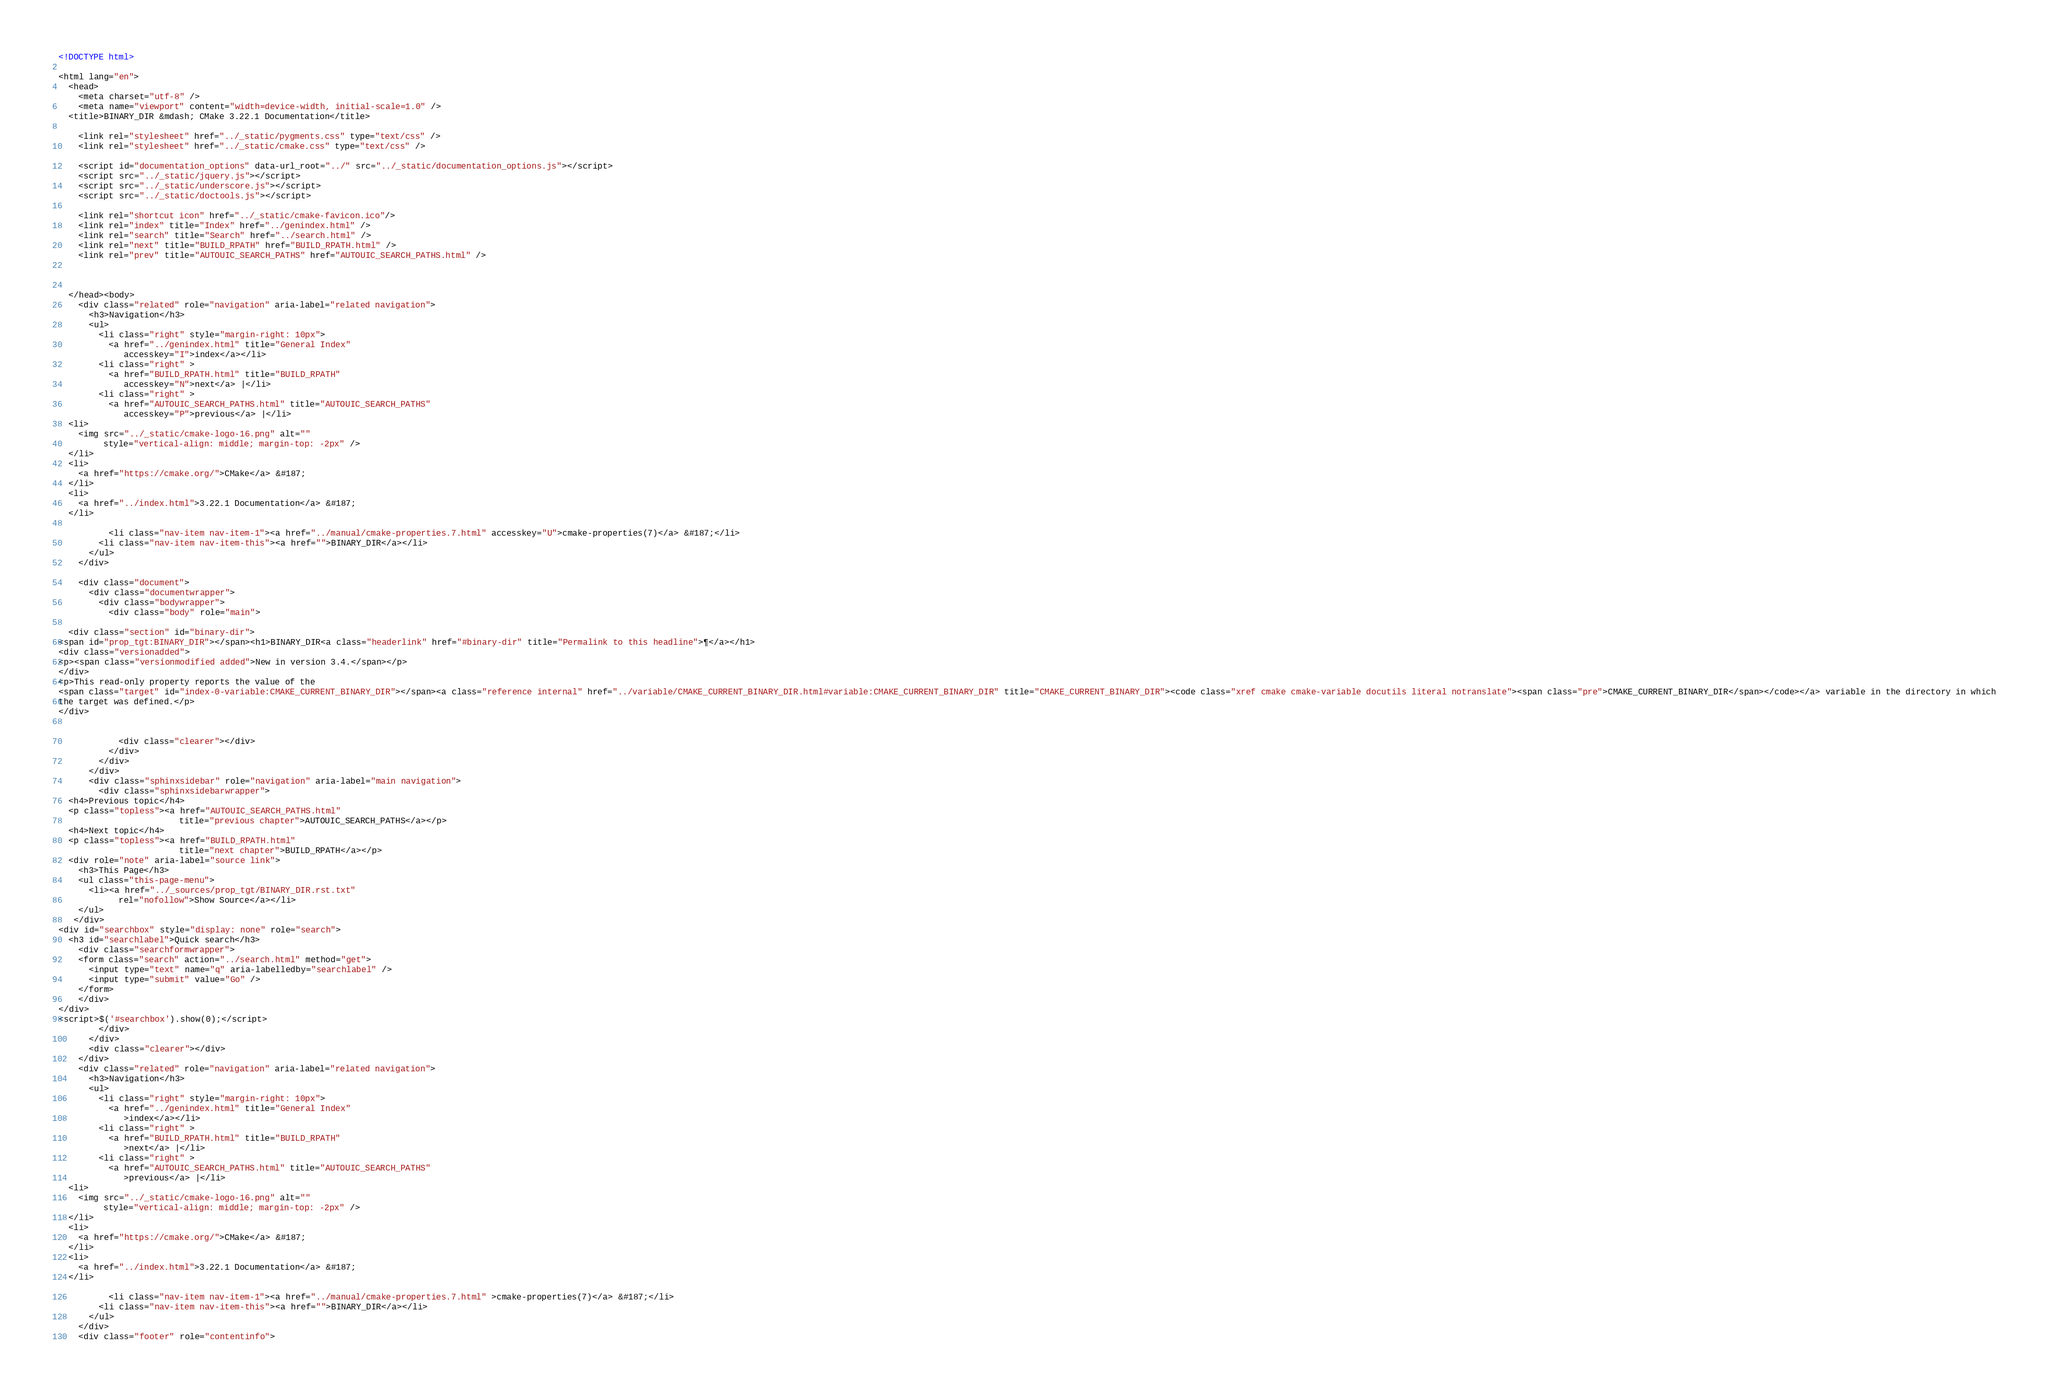Convert code to text. <code><loc_0><loc_0><loc_500><loc_500><_HTML_>
<!DOCTYPE html>

<html lang="en">
  <head>
    <meta charset="utf-8" />
    <meta name="viewport" content="width=device-width, initial-scale=1.0" />
  <title>BINARY_DIR &mdash; CMake 3.22.1 Documentation</title>

    <link rel="stylesheet" href="../_static/pygments.css" type="text/css" />
    <link rel="stylesheet" href="../_static/cmake.css" type="text/css" />
    
    <script id="documentation_options" data-url_root="../" src="../_static/documentation_options.js"></script>
    <script src="../_static/jquery.js"></script>
    <script src="../_static/underscore.js"></script>
    <script src="../_static/doctools.js"></script>
    
    <link rel="shortcut icon" href="../_static/cmake-favicon.ico"/>
    <link rel="index" title="Index" href="../genindex.html" />
    <link rel="search" title="Search" href="../search.html" />
    <link rel="next" title="BUILD_RPATH" href="BUILD_RPATH.html" />
    <link rel="prev" title="AUTOUIC_SEARCH_PATHS" href="AUTOUIC_SEARCH_PATHS.html" />
  
 

  </head><body>
    <div class="related" role="navigation" aria-label="related navigation">
      <h3>Navigation</h3>
      <ul>
        <li class="right" style="margin-right: 10px">
          <a href="../genindex.html" title="General Index"
             accesskey="I">index</a></li>
        <li class="right" >
          <a href="BUILD_RPATH.html" title="BUILD_RPATH"
             accesskey="N">next</a> |</li>
        <li class="right" >
          <a href="AUTOUIC_SEARCH_PATHS.html" title="AUTOUIC_SEARCH_PATHS"
             accesskey="P">previous</a> |</li>
  <li>
    <img src="../_static/cmake-logo-16.png" alt=""
         style="vertical-align: middle; margin-top: -2px" />
  </li>
  <li>
    <a href="https://cmake.org/">CMake</a> &#187;
  </li>
  <li>
    <a href="../index.html">3.22.1 Documentation</a> &#187;
  </li>

          <li class="nav-item nav-item-1"><a href="../manual/cmake-properties.7.html" accesskey="U">cmake-properties(7)</a> &#187;</li>
        <li class="nav-item nav-item-this"><a href="">BINARY_DIR</a></li> 
      </ul>
    </div>  

    <div class="document">
      <div class="documentwrapper">
        <div class="bodywrapper">
          <div class="body" role="main">
            
  <div class="section" id="binary-dir">
<span id="prop_tgt:BINARY_DIR"></span><h1>BINARY_DIR<a class="headerlink" href="#binary-dir" title="Permalink to this headline">¶</a></h1>
<div class="versionadded">
<p><span class="versionmodified added">New in version 3.4.</span></p>
</div>
<p>This read-only property reports the value of the
<span class="target" id="index-0-variable:CMAKE_CURRENT_BINARY_DIR"></span><a class="reference internal" href="../variable/CMAKE_CURRENT_BINARY_DIR.html#variable:CMAKE_CURRENT_BINARY_DIR" title="CMAKE_CURRENT_BINARY_DIR"><code class="xref cmake cmake-variable docutils literal notranslate"><span class="pre">CMAKE_CURRENT_BINARY_DIR</span></code></a> variable in the directory in which
the target was defined.</p>
</div>


            <div class="clearer"></div>
          </div>
        </div>
      </div>
      <div class="sphinxsidebar" role="navigation" aria-label="main navigation">
        <div class="sphinxsidebarwrapper">
  <h4>Previous topic</h4>
  <p class="topless"><a href="AUTOUIC_SEARCH_PATHS.html"
                        title="previous chapter">AUTOUIC_SEARCH_PATHS</a></p>
  <h4>Next topic</h4>
  <p class="topless"><a href="BUILD_RPATH.html"
                        title="next chapter">BUILD_RPATH</a></p>
  <div role="note" aria-label="source link">
    <h3>This Page</h3>
    <ul class="this-page-menu">
      <li><a href="../_sources/prop_tgt/BINARY_DIR.rst.txt"
            rel="nofollow">Show Source</a></li>
    </ul>
   </div>
<div id="searchbox" style="display: none" role="search">
  <h3 id="searchlabel">Quick search</h3>
    <div class="searchformwrapper">
    <form class="search" action="../search.html" method="get">
      <input type="text" name="q" aria-labelledby="searchlabel" />
      <input type="submit" value="Go" />
    </form>
    </div>
</div>
<script>$('#searchbox').show(0);</script>
        </div>
      </div>
      <div class="clearer"></div>
    </div>
    <div class="related" role="navigation" aria-label="related navigation">
      <h3>Navigation</h3>
      <ul>
        <li class="right" style="margin-right: 10px">
          <a href="../genindex.html" title="General Index"
             >index</a></li>
        <li class="right" >
          <a href="BUILD_RPATH.html" title="BUILD_RPATH"
             >next</a> |</li>
        <li class="right" >
          <a href="AUTOUIC_SEARCH_PATHS.html" title="AUTOUIC_SEARCH_PATHS"
             >previous</a> |</li>
  <li>
    <img src="../_static/cmake-logo-16.png" alt=""
         style="vertical-align: middle; margin-top: -2px" />
  </li>
  <li>
    <a href="https://cmake.org/">CMake</a> &#187;
  </li>
  <li>
    <a href="../index.html">3.22.1 Documentation</a> &#187;
  </li>

          <li class="nav-item nav-item-1"><a href="../manual/cmake-properties.7.html" >cmake-properties(7)</a> &#187;</li>
        <li class="nav-item nav-item-this"><a href="">BINARY_DIR</a></li> 
      </ul>
    </div>
    <div class="footer" role="contentinfo"></code> 